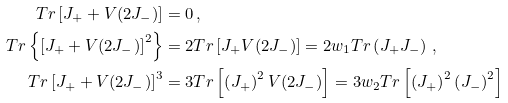<formula> <loc_0><loc_0><loc_500><loc_500>T r \left [ J _ { + } + V ( 2 J _ { - } ) \right ] & = 0 \, , \\ T r \left \{ \left [ J _ { + } + V ( 2 J _ { - } ) \right ] ^ { 2 } \right \} & = 2 T r \left [ J _ { + } V ( 2 J _ { - } ) \right ] = 2 w _ { 1 } T r \left ( J _ { + } J _ { - } \right ) \, , \\ T r \left [ J _ { + } + V ( 2 J _ { - } ) \right ] ^ { 3 } & = 3 T r \left [ \left ( J _ { + } \right ) ^ { 2 } V ( 2 J _ { - } ) \right ] = 3 w _ { 2 } T r \left [ \left ( J _ { + } \right ) ^ { 2 } \left ( J _ { - } \right ) ^ { 2 } \right ]</formula> 